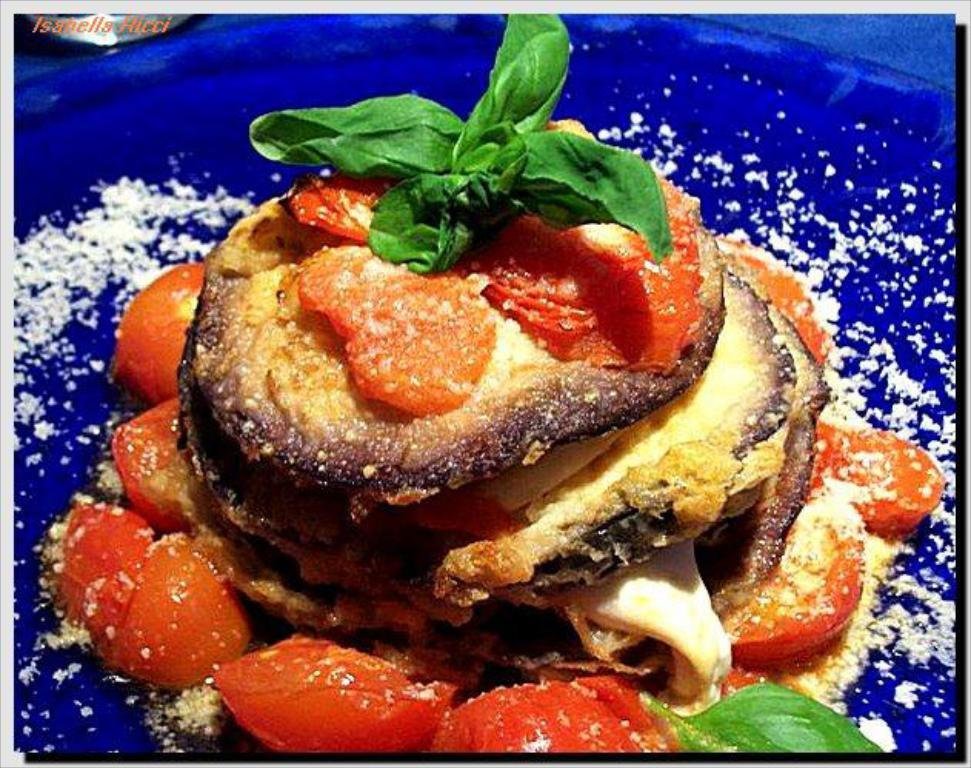What color is the object that contains food in the image? The object is blue. What type of food can be seen inside the blue object? The food has various colors, including brown, red, green, and cream. How does the pollution affect the moon in the image? There is no mention of pollution or the moon in the image; it only features a blue object containing food with various colors. 